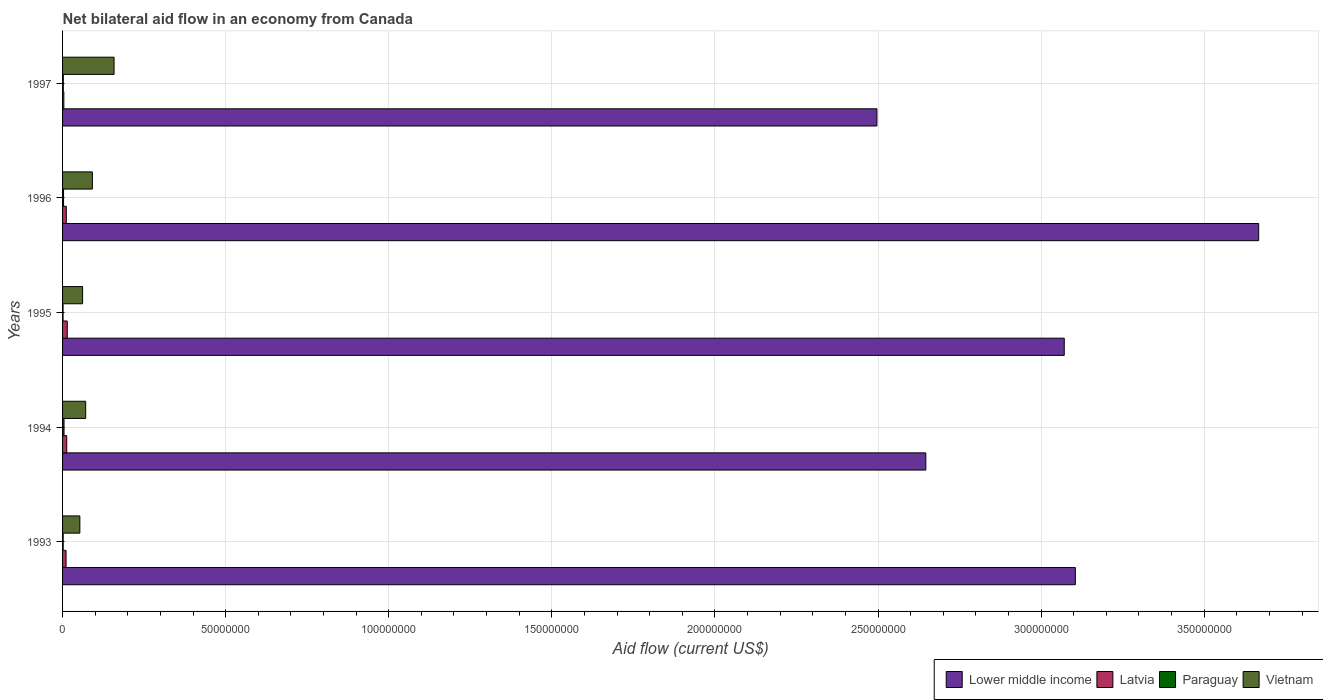How many different coloured bars are there?
Your response must be concise. 4. How many groups of bars are there?
Your response must be concise. 5. Are the number of bars per tick equal to the number of legend labels?
Your answer should be very brief. Yes. Are the number of bars on each tick of the Y-axis equal?
Give a very brief answer. Yes. How many bars are there on the 1st tick from the top?
Your answer should be very brief. 4. How many bars are there on the 2nd tick from the bottom?
Your answer should be compact. 4. What is the label of the 5th group of bars from the top?
Make the answer very short. 1993. In how many cases, is the number of bars for a given year not equal to the number of legend labels?
Offer a very short reply. 0. What is the net bilateral aid flow in Paraguay in 1994?
Your response must be concise. 4.50e+05. Across all years, what is the minimum net bilateral aid flow in Paraguay?
Make the answer very short. 1.50e+05. What is the total net bilateral aid flow in Paraguay in the graph?
Your answer should be very brief. 1.32e+06. What is the difference between the net bilateral aid flow in Lower middle income in 1993 and that in 1997?
Make the answer very short. 6.08e+07. What is the difference between the net bilateral aid flow in Paraguay in 1993 and the net bilateral aid flow in Lower middle income in 1995?
Give a very brief answer. -3.07e+08. What is the average net bilateral aid flow in Lower middle income per year?
Your response must be concise. 3.00e+08. In the year 1997, what is the difference between the net bilateral aid flow in Lower middle income and net bilateral aid flow in Vietnam?
Keep it short and to the point. 2.34e+08. What is the ratio of the net bilateral aid flow in Lower middle income in 1993 to that in 1994?
Your answer should be very brief. 1.17. What is the difference between the highest and the second highest net bilateral aid flow in Lower middle income?
Provide a short and direct response. 5.62e+07. What is the difference between the highest and the lowest net bilateral aid flow in Lower middle income?
Provide a short and direct response. 1.17e+08. In how many years, is the net bilateral aid flow in Lower middle income greater than the average net bilateral aid flow in Lower middle income taken over all years?
Ensure brevity in your answer.  3. Is the sum of the net bilateral aid flow in Vietnam in 1993 and 1995 greater than the maximum net bilateral aid flow in Paraguay across all years?
Provide a succinct answer. Yes. What does the 3rd bar from the top in 1993 represents?
Your answer should be compact. Latvia. What does the 4th bar from the bottom in 1997 represents?
Your response must be concise. Vietnam. How many bars are there?
Keep it short and to the point. 20. Are all the bars in the graph horizontal?
Your answer should be very brief. Yes. How many years are there in the graph?
Ensure brevity in your answer.  5. What is the difference between two consecutive major ticks on the X-axis?
Your response must be concise. 5.00e+07. Does the graph contain any zero values?
Your answer should be very brief. No. Where does the legend appear in the graph?
Your response must be concise. Bottom right. How many legend labels are there?
Your response must be concise. 4. What is the title of the graph?
Your answer should be very brief. Net bilateral aid flow in an economy from Canada. Does "St. Lucia" appear as one of the legend labels in the graph?
Your response must be concise. No. What is the label or title of the Y-axis?
Your answer should be very brief. Years. What is the Aid flow (current US$) in Lower middle income in 1993?
Your answer should be very brief. 3.10e+08. What is the Aid flow (current US$) of Latvia in 1993?
Ensure brevity in your answer.  1.07e+06. What is the Aid flow (current US$) in Paraguay in 1993?
Your response must be concise. 1.90e+05. What is the Aid flow (current US$) in Vietnam in 1993?
Provide a succinct answer. 5.30e+06. What is the Aid flow (current US$) of Lower middle income in 1994?
Offer a terse response. 2.65e+08. What is the Aid flow (current US$) of Latvia in 1994?
Your answer should be compact. 1.28e+06. What is the Aid flow (current US$) in Vietnam in 1994?
Your answer should be compact. 7.09e+06. What is the Aid flow (current US$) of Lower middle income in 1995?
Provide a short and direct response. 3.07e+08. What is the Aid flow (current US$) of Latvia in 1995?
Keep it short and to the point. 1.44e+06. What is the Aid flow (current US$) in Vietnam in 1995?
Ensure brevity in your answer.  6.14e+06. What is the Aid flow (current US$) of Lower middle income in 1996?
Your answer should be compact. 3.67e+08. What is the Aid flow (current US$) in Latvia in 1996?
Ensure brevity in your answer.  1.15e+06. What is the Aid flow (current US$) in Vietnam in 1996?
Keep it short and to the point. 9.14e+06. What is the Aid flow (current US$) in Lower middle income in 1997?
Provide a succinct answer. 2.50e+08. What is the Aid flow (current US$) in Vietnam in 1997?
Ensure brevity in your answer.  1.58e+07. Across all years, what is the maximum Aid flow (current US$) of Lower middle income?
Give a very brief answer. 3.67e+08. Across all years, what is the maximum Aid flow (current US$) in Latvia?
Ensure brevity in your answer.  1.44e+06. Across all years, what is the maximum Aid flow (current US$) in Paraguay?
Offer a terse response. 4.50e+05. Across all years, what is the maximum Aid flow (current US$) in Vietnam?
Give a very brief answer. 1.58e+07. Across all years, what is the minimum Aid flow (current US$) in Lower middle income?
Offer a terse response. 2.50e+08. Across all years, what is the minimum Aid flow (current US$) of Latvia?
Your response must be concise. 3.90e+05. Across all years, what is the minimum Aid flow (current US$) of Paraguay?
Provide a short and direct response. 1.50e+05. Across all years, what is the minimum Aid flow (current US$) of Vietnam?
Offer a terse response. 5.30e+06. What is the total Aid flow (current US$) in Lower middle income in the graph?
Ensure brevity in your answer.  1.50e+09. What is the total Aid flow (current US$) in Latvia in the graph?
Keep it short and to the point. 5.33e+06. What is the total Aid flow (current US$) of Paraguay in the graph?
Give a very brief answer. 1.32e+06. What is the total Aid flow (current US$) in Vietnam in the graph?
Offer a very short reply. 4.35e+07. What is the difference between the Aid flow (current US$) in Lower middle income in 1993 and that in 1994?
Provide a succinct answer. 4.58e+07. What is the difference between the Aid flow (current US$) of Latvia in 1993 and that in 1994?
Make the answer very short. -2.10e+05. What is the difference between the Aid flow (current US$) of Vietnam in 1993 and that in 1994?
Offer a terse response. -1.79e+06. What is the difference between the Aid flow (current US$) in Lower middle income in 1993 and that in 1995?
Give a very brief answer. 3.40e+06. What is the difference between the Aid flow (current US$) in Latvia in 1993 and that in 1995?
Offer a very short reply. -3.70e+05. What is the difference between the Aid flow (current US$) of Vietnam in 1993 and that in 1995?
Offer a terse response. -8.40e+05. What is the difference between the Aid flow (current US$) in Lower middle income in 1993 and that in 1996?
Offer a terse response. -5.62e+07. What is the difference between the Aid flow (current US$) of Latvia in 1993 and that in 1996?
Ensure brevity in your answer.  -8.00e+04. What is the difference between the Aid flow (current US$) in Vietnam in 1993 and that in 1996?
Your answer should be very brief. -3.84e+06. What is the difference between the Aid flow (current US$) of Lower middle income in 1993 and that in 1997?
Ensure brevity in your answer.  6.08e+07. What is the difference between the Aid flow (current US$) in Latvia in 1993 and that in 1997?
Keep it short and to the point. 6.80e+05. What is the difference between the Aid flow (current US$) in Vietnam in 1993 and that in 1997?
Your response must be concise. -1.05e+07. What is the difference between the Aid flow (current US$) in Lower middle income in 1994 and that in 1995?
Offer a very short reply. -4.24e+07. What is the difference between the Aid flow (current US$) of Paraguay in 1994 and that in 1995?
Your response must be concise. 3.00e+05. What is the difference between the Aid flow (current US$) of Vietnam in 1994 and that in 1995?
Make the answer very short. 9.50e+05. What is the difference between the Aid flow (current US$) of Lower middle income in 1994 and that in 1996?
Your answer should be very brief. -1.02e+08. What is the difference between the Aid flow (current US$) in Latvia in 1994 and that in 1996?
Provide a short and direct response. 1.30e+05. What is the difference between the Aid flow (current US$) of Vietnam in 1994 and that in 1996?
Keep it short and to the point. -2.05e+06. What is the difference between the Aid flow (current US$) in Lower middle income in 1994 and that in 1997?
Provide a succinct answer. 1.50e+07. What is the difference between the Aid flow (current US$) of Latvia in 1994 and that in 1997?
Provide a succinct answer. 8.90e+05. What is the difference between the Aid flow (current US$) of Paraguay in 1994 and that in 1997?
Provide a succinct answer. 2.20e+05. What is the difference between the Aid flow (current US$) of Vietnam in 1994 and that in 1997?
Your answer should be very brief. -8.70e+06. What is the difference between the Aid flow (current US$) in Lower middle income in 1995 and that in 1996?
Your answer should be compact. -5.96e+07. What is the difference between the Aid flow (current US$) of Paraguay in 1995 and that in 1996?
Your answer should be very brief. -1.50e+05. What is the difference between the Aid flow (current US$) of Lower middle income in 1995 and that in 1997?
Offer a very short reply. 5.74e+07. What is the difference between the Aid flow (current US$) of Latvia in 1995 and that in 1997?
Keep it short and to the point. 1.05e+06. What is the difference between the Aid flow (current US$) of Vietnam in 1995 and that in 1997?
Provide a succinct answer. -9.65e+06. What is the difference between the Aid flow (current US$) in Lower middle income in 1996 and that in 1997?
Your answer should be compact. 1.17e+08. What is the difference between the Aid flow (current US$) of Latvia in 1996 and that in 1997?
Provide a succinct answer. 7.60e+05. What is the difference between the Aid flow (current US$) in Vietnam in 1996 and that in 1997?
Offer a very short reply. -6.65e+06. What is the difference between the Aid flow (current US$) in Lower middle income in 1993 and the Aid flow (current US$) in Latvia in 1994?
Offer a terse response. 3.09e+08. What is the difference between the Aid flow (current US$) of Lower middle income in 1993 and the Aid flow (current US$) of Paraguay in 1994?
Make the answer very short. 3.10e+08. What is the difference between the Aid flow (current US$) of Lower middle income in 1993 and the Aid flow (current US$) of Vietnam in 1994?
Provide a succinct answer. 3.03e+08. What is the difference between the Aid flow (current US$) of Latvia in 1993 and the Aid flow (current US$) of Paraguay in 1994?
Make the answer very short. 6.20e+05. What is the difference between the Aid flow (current US$) in Latvia in 1993 and the Aid flow (current US$) in Vietnam in 1994?
Provide a short and direct response. -6.02e+06. What is the difference between the Aid flow (current US$) in Paraguay in 1993 and the Aid flow (current US$) in Vietnam in 1994?
Ensure brevity in your answer.  -6.90e+06. What is the difference between the Aid flow (current US$) in Lower middle income in 1993 and the Aid flow (current US$) in Latvia in 1995?
Provide a short and direct response. 3.09e+08. What is the difference between the Aid flow (current US$) of Lower middle income in 1993 and the Aid flow (current US$) of Paraguay in 1995?
Keep it short and to the point. 3.10e+08. What is the difference between the Aid flow (current US$) in Lower middle income in 1993 and the Aid flow (current US$) in Vietnam in 1995?
Make the answer very short. 3.04e+08. What is the difference between the Aid flow (current US$) in Latvia in 1993 and the Aid flow (current US$) in Paraguay in 1995?
Keep it short and to the point. 9.20e+05. What is the difference between the Aid flow (current US$) of Latvia in 1993 and the Aid flow (current US$) of Vietnam in 1995?
Your answer should be very brief. -5.07e+06. What is the difference between the Aid flow (current US$) in Paraguay in 1993 and the Aid flow (current US$) in Vietnam in 1995?
Your answer should be compact. -5.95e+06. What is the difference between the Aid flow (current US$) in Lower middle income in 1993 and the Aid flow (current US$) in Latvia in 1996?
Make the answer very short. 3.09e+08. What is the difference between the Aid flow (current US$) of Lower middle income in 1993 and the Aid flow (current US$) of Paraguay in 1996?
Offer a very short reply. 3.10e+08. What is the difference between the Aid flow (current US$) in Lower middle income in 1993 and the Aid flow (current US$) in Vietnam in 1996?
Offer a very short reply. 3.01e+08. What is the difference between the Aid flow (current US$) in Latvia in 1993 and the Aid flow (current US$) in Paraguay in 1996?
Provide a short and direct response. 7.70e+05. What is the difference between the Aid flow (current US$) in Latvia in 1993 and the Aid flow (current US$) in Vietnam in 1996?
Offer a very short reply. -8.07e+06. What is the difference between the Aid flow (current US$) of Paraguay in 1993 and the Aid flow (current US$) of Vietnam in 1996?
Provide a short and direct response. -8.95e+06. What is the difference between the Aid flow (current US$) in Lower middle income in 1993 and the Aid flow (current US$) in Latvia in 1997?
Provide a succinct answer. 3.10e+08. What is the difference between the Aid flow (current US$) in Lower middle income in 1993 and the Aid flow (current US$) in Paraguay in 1997?
Offer a terse response. 3.10e+08. What is the difference between the Aid flow (current US$) in Lower middle income in 1993 and the Aid flow (current US$) in Vietnam in 1997?
Your answer should be compact. 2.95e+08. What is the difference between the Aid flow (current US$) of Latvia in 1993 and the Aid flow (current US$) of Paraguay in 1997?
Offer a terse response. 8.40e+05. What is the difference between the Aid flow (current US$) of Latvia in 1993 and the Aid flow (current US$) of Vietnam in 1997?
Provide a short and direct response. -1.47e+07. What is the difference between the Aid flow (current US$) in Paraguay in 1993 and the Aid flow (current US$) in Vietnam in 1997?
Keep it short and to the point. -1.56e+07. What is the difference between the Aid flow (current US$) in Lower middle income in 1994 and the Aid flow (current US$) in Latvia in 1995?
Ensure brevity in your answer.  2.63e+08. What is the difference between the Aid flow (current US$) of Lower middle income in 1994 and the Aid flow (current US$) of Paraguay in 1995?
Your answer should be compact. 2.65e+08. What is the difference between the Aid flow (current US$) in Lower middle income in 1994 and the Aid flow (current US$) in Vietnam in 1995?
Offer a terse response. 2.59e+08. What is the difference between the Aid flow (current US$) in Latvia in 1994 and the Aid flow (current US$) in Paraguay in 1995?
Your answer should be very brief. 1.13e+06. What is the difference between the Aid flow (current US$) of Latvia in 1994 and the Aid flow (current US$) of Vietnam in 1995?
Your answer should be very brief. -4.86e+06. What is the difference between the Aid flow (current US$) in Paraguay in 1994 and the Aid flow (current US$) in Vietnam in 1995?
Ensure brevity in your answer.  -5.69e+06. What is the difference between the Aid flow (current US$) of Lower middle income in 1994 and the Aid flow (current US$) of Latvia in 1996?
Your answer should be compact. 2.64e+08. What is the difference between the Aid flow (current US$) of Lower middle income in 1994 and the Aid flow (current US$) of Paraguay in 1996?
Provide a succinct answer. 2.64e+08. What is the difference between the Aid flow (current US$) in Lower middle income in 1994 and the Aid flow (current US$) in Vietnam in 1996?
Keep it short and to the point. 2.56e+08. What is the difference between the Aid flow (current US$) of Latvia in 1994 and the Aid flow (current US$) of Paraguay in 1996?
Your answer should be compact. 9.80e+05. What is the difference between the Aid flow (current US$) of Latvia in 1994 and the Aid flow (current US$) of Vietnam in 1996?
Offer a terse response. -7.86e+06. What is the difference between the Aid flow (current US$) in Paraguay in 1994 and the Aid flow (current US$) in Vietnam in 1996?
Offer a terse response. -8.69e+06. What is the difference between the Aid flow (current US$) of Lower middle income in 1994 and the Aid flow (current US$) of Latvia in 1997?
Provide a short and direct response. 2.64e+08. What is the difference between the Aid flow (current US$) in Lower middle income in 1994 and the Aid flow (current US$) in Paraguay in 1997?
Offer a terse response. 2.64e+08. What is the difference between the Aid flow (current US$) of Lower middle income in 1994 and the Aid flow (current US$) of Vietnam in 1997?
Provide a short and direct response. 2.49e+08. What is the difference between the Aid flow (current US$) of Latvia in 1994 and the Aid flow (current US$) of Paraguay in 1997?
Offer a terse response. 1.05e+06. What is the difference between the Aid flow (current US$) of Latvia in 1994 and the Aid flow (current US$) of Vietnam in 1997?
Make the answer very short. -1.45e+07. What is the difference between the Aid flow (current US$) of Paraguay in 1994 and the Aid flow (current US$) of Vietnam in 1997?
Your answer should be compact. -1.53e+07. What is the difference between the Aid flow (current US$) in Lower middle income in 1995 and the Aid flow (current US$) in Latvia in 1996?
Provide a short and direct response. 3.06e+08. What is the difference between the Aid flow (current US$) of Lower middle income in 1995 and the Aid flow (current US$) of Paraguay in 1996?
Ensure brevity in your answer.  3.07e+08. What is the difference between the Aid flow (current US$) of Lower middle income in 1995 and the Aid flow (current US$) of Vietnam in 1996?
Offer a very short reply. 2.98e+08. What is the difference between the Aid flow (current US$) of Latvia in 1995 and the Aid flow (current US$) of Paraguay in 1996?
Ensure brevity in your answer.  1.14e+06. What is the difference between the Aid flow (current US$) in Latvia in 1995 and the Aid flow (current US$) in Vietnam in 1996?
Provide a short and direct response. -7.70e+06. What is the difference between the Aid flow (current US$) in Paraguay in 1995 and the Aid flow (current US$) in Vietnam in 1996?
Ensure brevity in your answer.  -8.99e+06. What is the difference between the Aid flow (current US$) of Lower middle income in 1995 and the Aid flow (current US$) of Latvia in 1997?
Provide a short and direct response. 3.07e+08. What is the difference between the Aid flow (current US$) of Lower middle income in 1995 and the Aid flow (current US$) of Paraguay in 1997?
Your answer should be very brief. 3.07e+08. What is the difference between the Aid flow (current US$) in Lower middle income in 1995 and the Aid flow (current US$) in Vietnam in 1997?
Your response must be concise. 2.91e+08. What is the difference between the Aid flow (current US$) of Latvia in 1995 and the Aid flow (current US$) of Paraguay in 1997?
Make the answer very short. 1.21e+06. What is the difference between the Aid flow (current US$) in Latvia in 1995 and the Aid flow (current US$) in Vietnam in 1997?
Provide a short and direct response. -1.44e+07. What is the difference between the Aid flow (current US$) in Paraguay in 1995 and the Aid flow (current US$) in Vietnam in 1997?
Provide a short and direct response. -1.56e+07. What is the difference between the Aid flow (current US$) in Lower middle income in 1996 and the Aid flow (current US$) in Latvia in 1997?
Give a very brief answer. 3.66e+08. What is the difference between the Aid flow (current US$) of Lower middle income in 1996 and the Aid flow (current US$) of Paraguay in 1997?
Offer a very short reply. 3.66e+08. What is the difference between the Aid flow (current US$) of Lower middle income in 1996 and the Aid flow (current US$) of Vietnam in 1997?
Keep it short and to the point. 3.51e+08. What is the difference between the Aid flow (current US$) of Latvia in 1996 and the Aid flow (current US$) of Paraguay in 1997?
Your answer should be very brief. 9.20e+05. What is the difference between the Aid flow (current US$) of Latvia in 1996 and the Aid flow (current US$) of Vietnam in 1997?
Offer a terse response. -1.46e+07. What is the difference between the Aid flow (current US$) in Paraguay in 1996 and the Aid flow (current US$) in Vietnam in 1997?
Keep it short and to the point. -1.55e+07. What is the average Aid flow (current US$) in Lower middle income per year?
Ensure brevity in your answer.  3.00e+08. What is the average Aid flow (current US$) in Latvia per year?
Provide a short and direct response. 1.07e+06. What is the average Aid flow (current US$) of Paraguay per year?
Keep it short and to the point. 2.64e+05. What is the average Aid flow (current US$) in Vietnam per year?
Provide a succinct answer. 8.69e+06. In the year 1993, what is the difference between the Aid flow (current US$) of Lower middle income and Aid flow (current US$) of Latvia?
Provide a short and direct response. 3.09e+08. In the year 1993, what is the difference between the Aid flow (current US$) of Lower middle income and Aid flow (current US$) of Paraguay?
Give a very brief answer. 3.10e+08. In the year 1993, what is the difference between the Aid flow (current US$) of Lower middle income and Aid flow (current US$) of Vietnam?
Your answer should be compact. 3.05e+08. In the year 1993, what is the difference between the Aid flow (current US$) of Latvia and Aid flow (current US$) of Paraguay?
Give a very brief answer. 8.80e+05. In the year 1993, what is the difference between the Aid flow (current US$) of Latvia and Aid flow (current US$) of Vietnam?
Provide a succinct answer. -4.23e+06. In the year 1993, what is the difference between the Aid flow (current US$) in Paraguay and Aid flow (current US$) in Vietnam?
Keep it short and to the point. -5.11e+06. In the year 1994, what is the difference between the Aid flow (current US$) in Lower middle income and Aid flow (current US$) in Latvia?
Your answer should be compact. 2.63e+08. In the year 1994, what is the difference between the Aid flow (current US$) in Lower middle income and Aid flow (current US$) in Paraguay?
Offer a terse response. 2.64e+08. In the year 1994, what is the difference between the Aid flow (current US$) in Lower middle income and Aid flow (current US$) in Vietnam?
Offer a very short reply. 2.58e+08. In the year 1994, what is the difference between the Aid flow (current US$) in Latvia and Aid flow (current US$) in Paraguay?
Make the answer very short. 8.30e+05. In the year 1994, what is the difference between the Aid flow (current US$) in Latvia and Aid flow (current US$) in Vietnam?
Ensure brevity in your answer.  -5.81e+06. In the year 1994, what is the difference between the Aid flow (current US$) of Paraguay and Aid flow (current US$) of Vietnam?
Keep it short and to the point. -6.64e+06. In the year 1995, what is the difference between the Aid flow (current US$) in Lower middle income and Aid flow (current US$) in Latvia?
Your answer should be very brief. 3.06e+08. In the year 1995, what is the difference between the Aid flow (current US$) in Lower middle income and Aid flow (current US$) in Paraguay?
Provide a succinct answer. 3.07e+08. In the year 1995, what is the difference between the Aid flow (current US$) of Lower middle income and Aid flow (current US$) of Vietnam?
Provide a short and direct response. 3.01e+08. In the year 1995, what is the difference between the Aid flow (current US$) in Latvia and Aid flow (current US$) in Paraguay?
Your answer should be compact. 1.29e+06. In the year 1995, what is the difference between the Aid flow (current US$) of Latvia and Aid flow (current US$) of Vietnam?
Provide a short and direct response. -4.70e+06. In the year 1995, what is the difference between the Aid flow (current US$) of Paraguay and Aid flow (current US$) of Vietnam?
Ensure brevity in your answer.  -5.99e+06. In the year 1996, what is the difference between the Aid flow (current US$) in Lower middle income and Aid flow (current US$) in Latvia?
Offer a very short reply. 3.66e+08. In the year 1996, what is the difference between the Aid flow (current US$) of Lower middle income and Aid flow (current US$) of Paraguay?
Keep it short and to the point. 3.66e+08. In the year 1996, what is the difference between the Aid flow (current US$) in Lower middle income and Aid flow (current US$) in Vietnam?
Ensure brevity in your answer.  3.58e+08. In the year 1996, what is the difference between the Aid flow (current US$) of Latvia and Aid flow (current US$) of Paraguay?
Make the answer very short. 8.50e+05. In the year 1996, what is the difference between the Aid flow (current US$) of Latvia and Aid flow (current US$) of Vietnam?
Offer a terse response. -7.99e+06. In the year 1996, what is the difference between the Aid flow (current US$) of Paraguay and Aid flow (current US$) of Vietnam?
Your answer should be very brief. -8.84e+06. In the year 1997, what is the difference between the Aid flow (current US$) in Lower middle income and Aid flow (current US$) in Latvia?
Ensure brevity in your answer.  2.49e+08. In the year 1997, what is the difference between the Aid flow (current US$) of Lower middle income and Aid flow (current US$) of Paraguay?
Your answer should be compact. 2.49e+08. In the year 1997, what is the difference between the Aid flow (current US$) in Lower middle income and Aid flow (current US$) in Vietnam?
Give a very brief answer. 2.34e+08. In the year 1997, what is the difference between the Aid flow (current US$) of Latvia and Aid flow (current US$) of Vietnam?
Offer a very short reply. -1.54e+07. In the year 1997, what is the difference between the Aid flow (current US$) of Paraguay and Aid flow (current US$) of Vietnam?
Keep it short and to the point. -1.56e+07. What is the ratio of the Aid flow (current US$) in Lower middle income in 1993 to that in 1994?
Give a very brief answer. 1.17. What is the ratio of the Aid flow (current US$) in Latvia in 1993 to that in 1994?
Keep it short and to the point. 0.84. What is the ratio of the Aid flow (current US$) of Paraguay in 1993 to that in 1994?
Offer a terse response. 0.42. What is the ratio of the Aid flow (current US$) of Vietnam in 1993 to that in 1994?
Ensure brevity in your answer.  0.75. What is the ratio of the Aid flow (current US$) of Lower middle income in 1993 to that in 1995?
Offer a terse response. 1.01. What is the ratio of the Aid flow (current US$) in Latvia in 1993 to that in 1995?
Offer a very short reply. 0.74. What is the ratio of the Aid flow (current US$) of Paraguay in 1993 to that in 1995?
Keep it short and to the point. 1.27. What is the ratio of the Aid flow (current US$) in Vietnam in 1993 to that in 1995?
Give a very brief answer. 0.86. What is the ratio of the Aid flow (current US$) in Lower middle income in 1993 to that in 1996?
Offer a terse response. 0.85. What is the ratio of the Aid flow (current US$) in Latvia in 1993 to that in 1996?
Give a very brief answer. 0.93. What is the ratio of the Aid flow (current US$) in Paraguay in 1993 to that in 1996?
Ensure brevity in your answer.  0.63. What is the ratio of the Aid flow (current US$) in Vietnam in 1993 to that in 1996?
Offer a terse response. 0.58. What is the ratio of the Aid flow (current US$) in Lower middle income in 1993 to that in 1997?
Your answer should be compact. 1.24. What is the ratio of the Aid flow (current US$) in Latvia in 1993 to that in 1997?
Your answer should be very brief. 2.74. What is the ratio of the Aid flow (current US$) of Paraguay in 1993 to that in 1997?
Ensure brevity in your answer.  0.83. What is the ratio of the Aid flow (current US$) of Vietnam in 1993 to that in 1997?
Keep it short and to the point. 0.34. What is the ratio of the Aid flow (current US$) of Lower middle income in 1994 to that in 1995?
Keep it short and to the point. 0.86. What is the ratio of the Aid flow (current US$) in Latvia in 1994 to that in 1995?
Your response must be concise. 0.89. What is the ratio of the Aid flow (current US$) of Vietnam in 1994 to that in 1995?
Provide a short and direct response. 1.15. What is the ratio of the Aid flow (current US$) of Lower middle income in 1994 to that in 1996?
Give a very brief answer. 0.72. What is the ratio of the Aid flow (current US$) in Latvia in 1994 to that in 1996?
Make the answer very short. 1.11. What is the ratio of the Aid flow (current US$) of Vietnam in 1994 to that in 1996?
Offer a very short reply. 0.78. What is the ratio of the Aid flow (current US$) of Lower middle income in 1994 to that in 1997?
Ensure brevity in your answer.  1.06. What is the ratio of the Aid flow (current US$) in Latvia in 1994 to that in 1997?
Offer a terse response. 3.28. What is the ratio of the Aid flow (current US$) in Paraguay in 1994 to that in 1997?
Keep it short and to the point. 1.96. What is the ratio of the Aid flow (current US$) in Vietnam in 1994 to that in 1997?
Keep it short and to the point. 0.45. What is the ratio of the Aid flow (current US$) in Lower middle income in 1995 to that in 1996?
Your answer should be very brief. 0.84. What is the ratio of the Aid flow (current US$) in Latvia in 1995 to that in 1996?
Your response must be concise. 1.25. What is the ratio of the Aid flow (current US$) of Paraguay in 1995 to that in 1996?
Offer a very short reply. 0.5. What is the ratio of the Aid flow (current US$) of Vietnam in 1995 to that in 1996?
Ensure brevity in your answer.  0.67. What is the ratio of the Aid flow (current US$) in Lower middle income in 1995 to that in 1997?
Offer a very short reply. 1.23. What is the ratio of the Aid flow (current US$) of Latvia in 1995 to that in 1997?
Give a very brief answer. 3.69. What is the ratio of the Aid flow (current US$) in Paraguay in 1995 to that in 1997?
Keep it short and to the point. 0.65. What is the ratio of the Aid flow (current US$) of Vietnam in 1995 to that in 1997?
Make the answer very short. 0.39. What is the ratio of the Aid flow (current US$) in Lower middle income in 1996 to that in 1997?
Ensure brevity in your answer.  1.47. What is the ratio of the Aid flow (current US$) in Latvia in 1996 to that in 1997?
Your answer should be compact. 2.95. What is the ratio of the Aid flow (current US$) in Paraguay in 1996 to that in 1997?
Ensure brevity in your answer.  1.3. What is the ratio of the Aid flow (current US$) in Vietnam in 1996 to that in 1997?
Offer a very short reply. 0.58. What is the difference between the highest and the second highest Aid flow (current US$) of Lower middle income?
Your response must be concise. 5.62e+07. What is the difference between the highest and the second highest Aid flow (current US$) of Latvia?
Make the answer very short. 1.60e+05. What is the difference between the highest and the second highest Aid flow (current US$) in Vietnam?
Give a very brief answer. 6.65e+06. What is the difference between the highest and the lowest Aid flow (current US$) in Lower middle income?
Your response must be concise. 1.17e+08. What is the difference between the highest and the lowest Aid flow (current US$) in Latvia?
Ensure brevity in your answer.  1.05e+06. What is the difference between the highest and the lowest Aid flow (current US$) in Paraguay?
Your answer should be compact. 3.00e+05. What is the difference between the highest and the lowest Aid flow (current US$) in Vietnam?
Your response must be concise. 1.05e+07. 